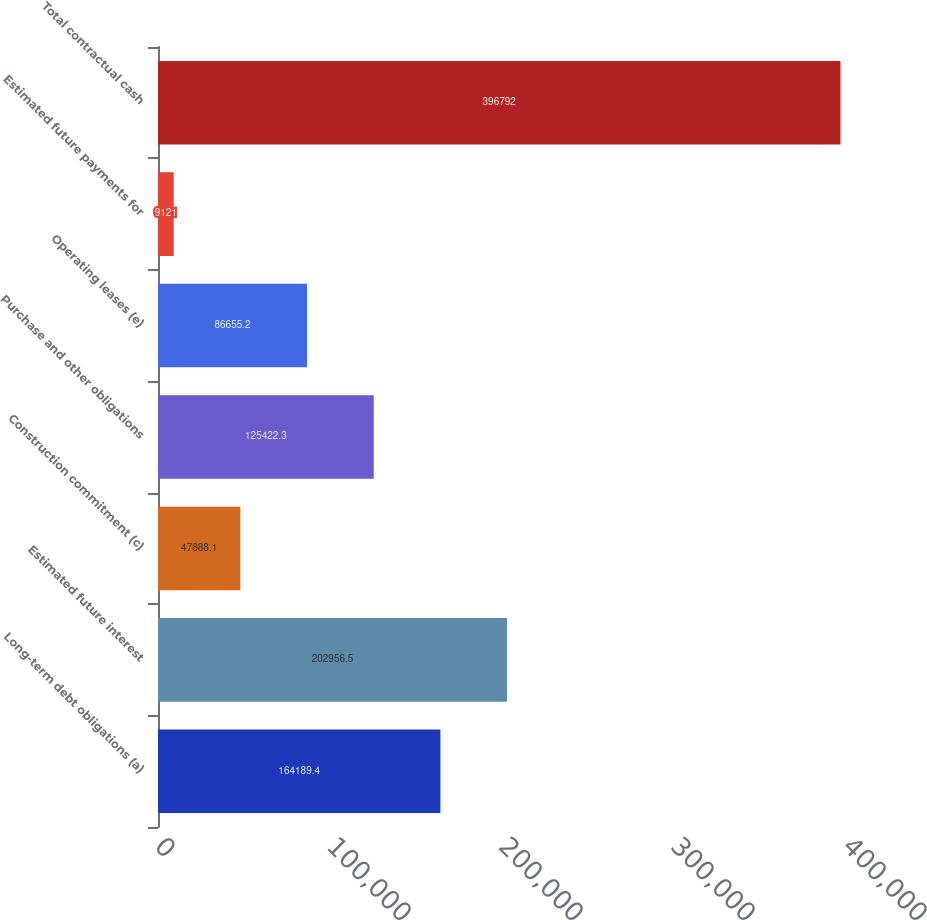Convert chart to OTSL. <chart><loc_0><loc_0><loc_500><loc_500><bar_chart><fcel>Long-term debt obligations (a)<fcel>Estimated future interest<fcel>Construction commitment (c)<fcel>Purchase and other obligations<fcel>Operating leases (e)<fcel>Estimated future payments for<fcel>Total contractual cash<nl><fcel>164189<fcel>202956<fcel>47888.1<fcel>125422<fcel>86655.2<fcel>9121<fcel>396792<nl></chart> 